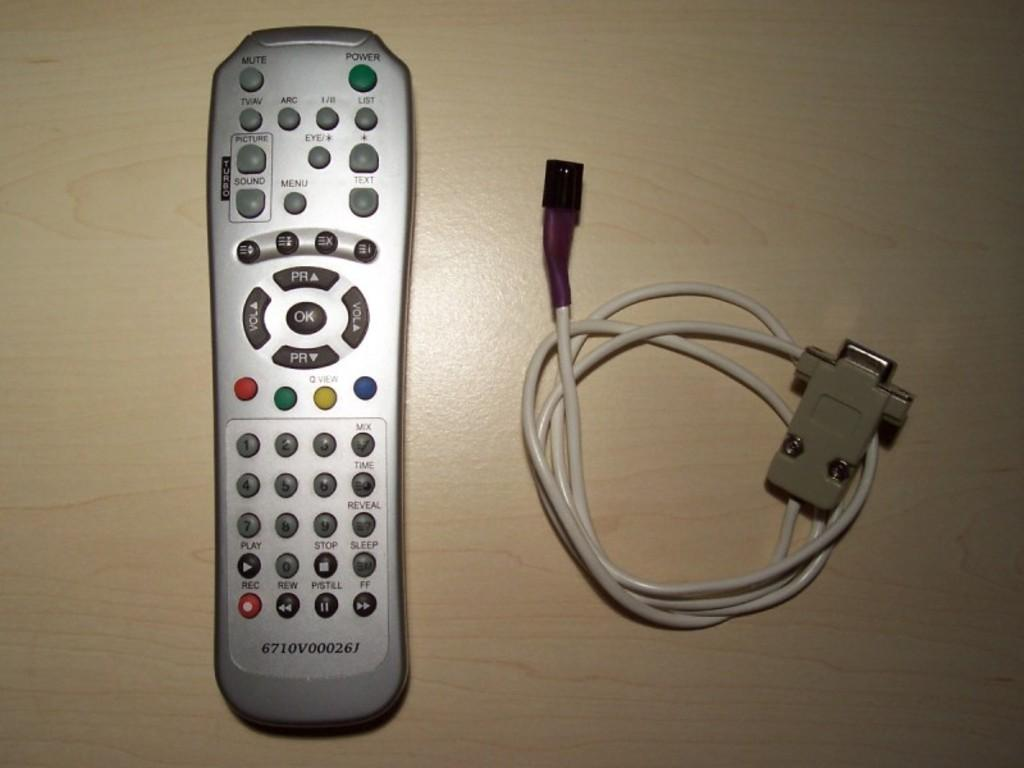<image>
Offer a succinct explanation of the picture presented. A silver turbo branded television remote control with a wire sitting next to it. 